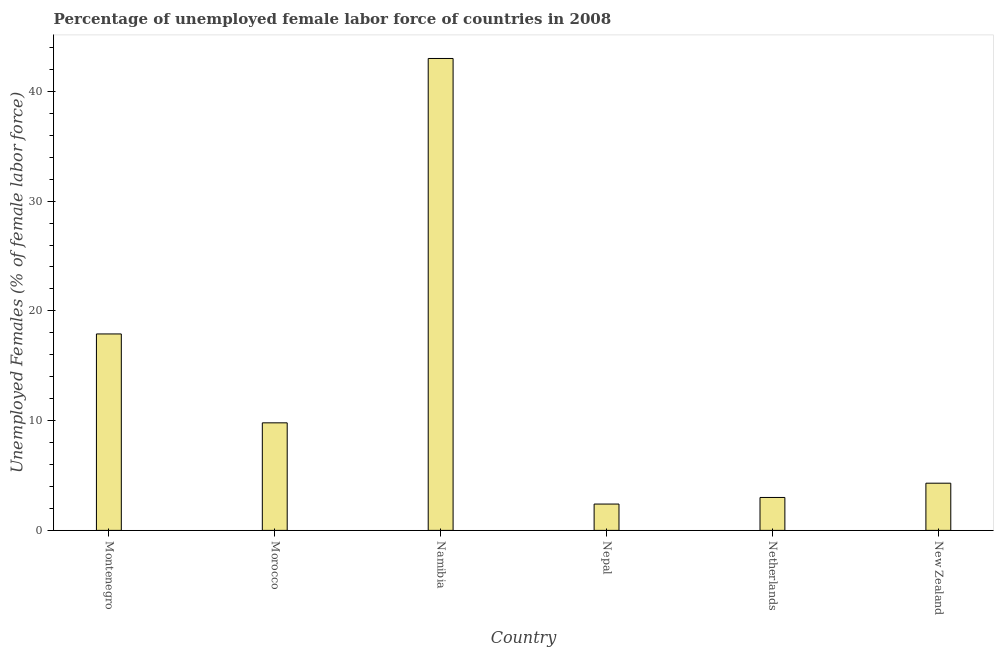Does the graph contain grids?
Keep it short and to the point. No. What is the title of the graph?
Provide a short and direct response. Percentage of unemployed female labor force of countries in 2008. What is the label or title of the X-axis?
Your answer should be compact. Country. What is the label or title of the Y-axis?
Provide a short and direct response. Unemployed Females (% of female labor force). What is the total unemployed female labour force in Nepal?
Ensure brevity in your answer.  2.4. Across all countries, what is the maximum total unemployed female labour force?
Offer a terse response. 43. Across all countries, what is the minimum total unemployed female labour force?
Your response must be concise. 2.4. In which country was the total unemployed female labour force maximum?
Make the answer very short. Namibia. In which country was the total unemployed female labour force minimum?
Give a very brief answer. Nepal. What is the sum of the total unemployed female labour force?
Your answer should be compact. 80.4. What is the difference between the total unemployed female labour force in Morocco and New Zealand?
Your answer should be very brief. 5.5. What is the median total unemployed female labour force?
Provide a succinct answer. 7.05. What is the ratio of the total unemployed female labour force in Namibia to that in Nepal?
Your answer should be compact. 17.92. Is the difference between the total unemployed female labour force in Netherlands and New Zealand greater than the difference between any two countries?
Ensure brevity in your answer.  No. What is the difference between the highest and the second highest total unemployed female labour force?
Provide a short and direct response. 25.1. What is the difference between the highest and the lowest total unemployed female labour force?
Your answer should be very brief. 40.6. Are all the bars in the graph horizontal?
Ensure brevity in your answer.  No. Are the values on the major ticks of Y-axis written in scientific E-notation?
Ensure brevity in your answer.  No. What is the Unemployed Females (% of female labor force) in Montenegro?
Give a very brief answer. 17.9. What is the Unemployed Females (% of female labor force) of Morocco?
Ensure brevity in your answer.  9.8. What is the Unemployed Females (% of female labor force) of Nepal?
Provide a short and direct response. 2.4. What is the Unemployed Females (% of female labor force) of New Zealand?
Your response must be concise. 4.3. What is the difference between the Unemployed Females (% of female labor force) in Montenegro and Morocco?
Ensure brevity in your answer.  8.1. What is the difference between the Unemployed Females (% of female labor force) in Montenegro and Namibia?
Your answer should be very brief. -25.1. What is the difference between the Unemployed Females (% of female labor force) in Montenegro and Nepal?
Give a very brief answer. 15.5. What is the difference between the Unemployed Females (% of female labor force) in Montenegro and New Zealand?
Keep it short and to the point. 13.6. What is the difference between the Unemployed Females (% of female labor force) in Morocco and Namibia?
Offer a very short reply. -33.2. What is the difference between the Unemployed Females (% of female labor force) in Namibia and Nepal?
Your answer should be compact. 40.6. What is the difference between the Unemployed Females (% of female labor force) in Namibia and New Zealand?
Provide a succinct answer. 38.7. What is the difference between the Unemployed Females (% of female labor force) in Nepal and Netherlands?
Offer a very short reply. -0.6. What is the difference between the Unemployed Females (% of female labor force) in Netherlands and New Zealand?
Give a very brief answer. -1.3. What is the ratio of the Unemployed Females (% of female labor force) in Montenegro to that in Morocco?
Your response must be concise. 1.83. What is the ratio of the Unemployed Females (% of female labor force) in Montenegro to that in Namibia?
Offer a very short reply. 0.42. What is the ratio of the Unemployed Females (% of female labor force) in Montenegro to that in Nepal?
Offer a terse response. 7.46. What is the ratio of the Unemployed Females (% of female labor force) in Montenegro to that in Netherlands?
Ensure brevity in your answer.  5.97. What is the ratio of the Unemployed Females (% of female labor force) in Montenegro to that in New Zealand?
Provide a short and direct response. 4.16. What is the ratio of the Unemployed Females (% of female labor force) in Morocco to that in Namibia?
Offer a very short reply. 0.23. What is the ratio of the Unemployed Females (% of female labor force) in Morocco to that in Nepal?
Offer a very short reply. 4.08. What is the ratio of the Unemployed Females (% of female labor force) in Morocco to that in Netherlands?
Your answer should be compact. 3.27. What is the ratio of the Unemployed Females (% of female labor force) in Morocco to that in New Zealand?
Make the answer very short. 2.28. What is the ratio of the Unemployed Females (% of female labor force) in Namibia to that in Nepal?
Your answer should be very brief. 17.92. What is the ratio of the Unemployed Females (% of female labor force) in Namibia to that in Netherlands?
Your answer should be very brief. 14.33. What is the ratio of the Unemployed Females (% of female labor force) in Namibia to that in New Zealand?
Give a very brief answer. 10. What is the ratio of the Unemployed Females (% of female labor force) in Nepal to that in New Zealand?
Give a very brief answer. 0.56. What is the ratio of the Unemployed Females (% of female labor force) in Netherlands to that in New Zealand?
Provide a short and direct response. 0.7. 